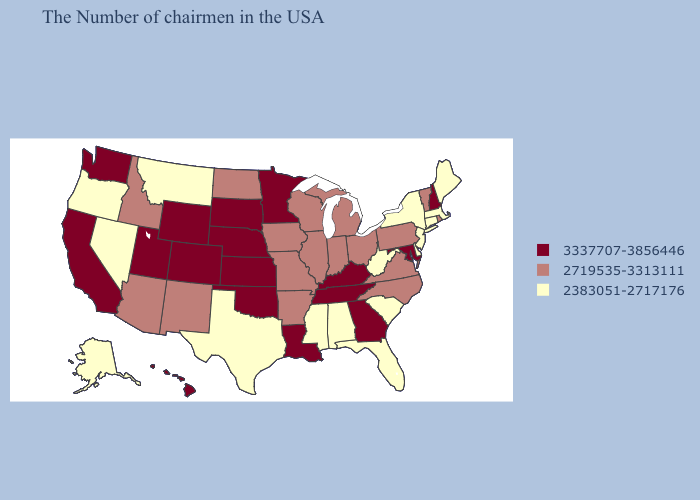Which states have the highest value in the USA?
Keep it brief. New Hampshire, Maryland, Georgia, Kentucky, Tennessee, Louisiana, Minnesota, Kansas, Nebraska, Oklahoma, South Dakota, Wyoming, Colorado, Utah, California, Washington, Hawaii. Among the states that border Kentucky , does Ohio have the highest value?
Write a very short answer. No. Name the states that have a value in the range 3337707-3856446?
Short answer required. New Hampshire, Maryland, Georgia, Kentucky, Tennessee, Louisiana, Minnesota, Kansas, Nebraska, Oklahoma, South Dakota, Wyoming, Colorado, Utah, California, Washington, Hawaii. Among the states that border South Dakota , does North Dakota have the highest value?
Be succinct. No. Among the states that border Wyoming , which have the highest value?
Write a very short answer. Nebraska, South Dakota, Colorado, Utah. Name the states that have a value in the range 3337707-3856446?
Be succinct. New Hampshire, Maryland, Georgia, Kentucky, Tennessee, Louisiana, Minnesota, Kansas, Nebraska, Oklahoma, South Dakota, Wyoming, Colorado, Utah, California, Washington, Hawaii. What is the value of Virginia?
Answer briefly. 2719535-3313111. Which states have the lowest value in the South?
Concise answer only. Delaware, South Carolina, West Virginia, Florida, Alabama, Mississippi, Texas. What is the value of Nebraska?
Answer briefly. 3337707-3856446. Name the states that have a value in the range 2383051-2717176?
Be succinct. Maine, Massachusetts, Connecticut, New York, New Jersey, Delaware, South Carolina, West Virginia, Florida, Alabama, Mississippi, Texas, Montana, Nevada, Oregon, Alaska. Does Maine have a lower value than Delaware?
Short answer required. No. Name the states that have a value in the range 2383051-2717176?
Give a very brief answer. Maine, Massachusetts, Connecticut, New York, New Jersey, Delaware, South Carolina, West Virginia, Florida, Alabama, Mississippi, Texas, Montana, Nevada, Oregon, Alaska. What is the value of California?
Answer briefly. 3337707-3856446. What is the highest value in the USA?
Keep it brief. 3337707-3856446. Among the states that border Arizona , which have the lowest value?
Concise answer only. Nevada. 